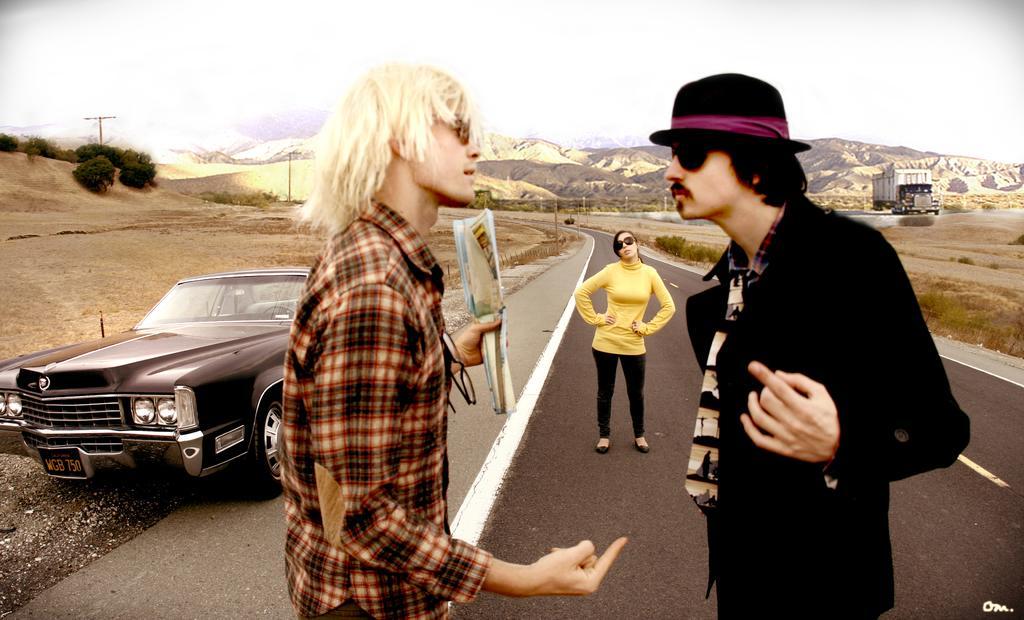Could you give a brief overview of what you see in this image? In the picture we can see two men are standing on the road and talking and far away from them, we can see a woman standing and watching them and beside her we can see the car and in the background we can see the truck, poles, hills and the sky. 